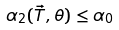<formula> <loc_0><loc_0><loc_500><loc_500>\alpha _ { 2 } ( \vec { T } , \theta ) \leq \alpha _ { 0 }</formula> 